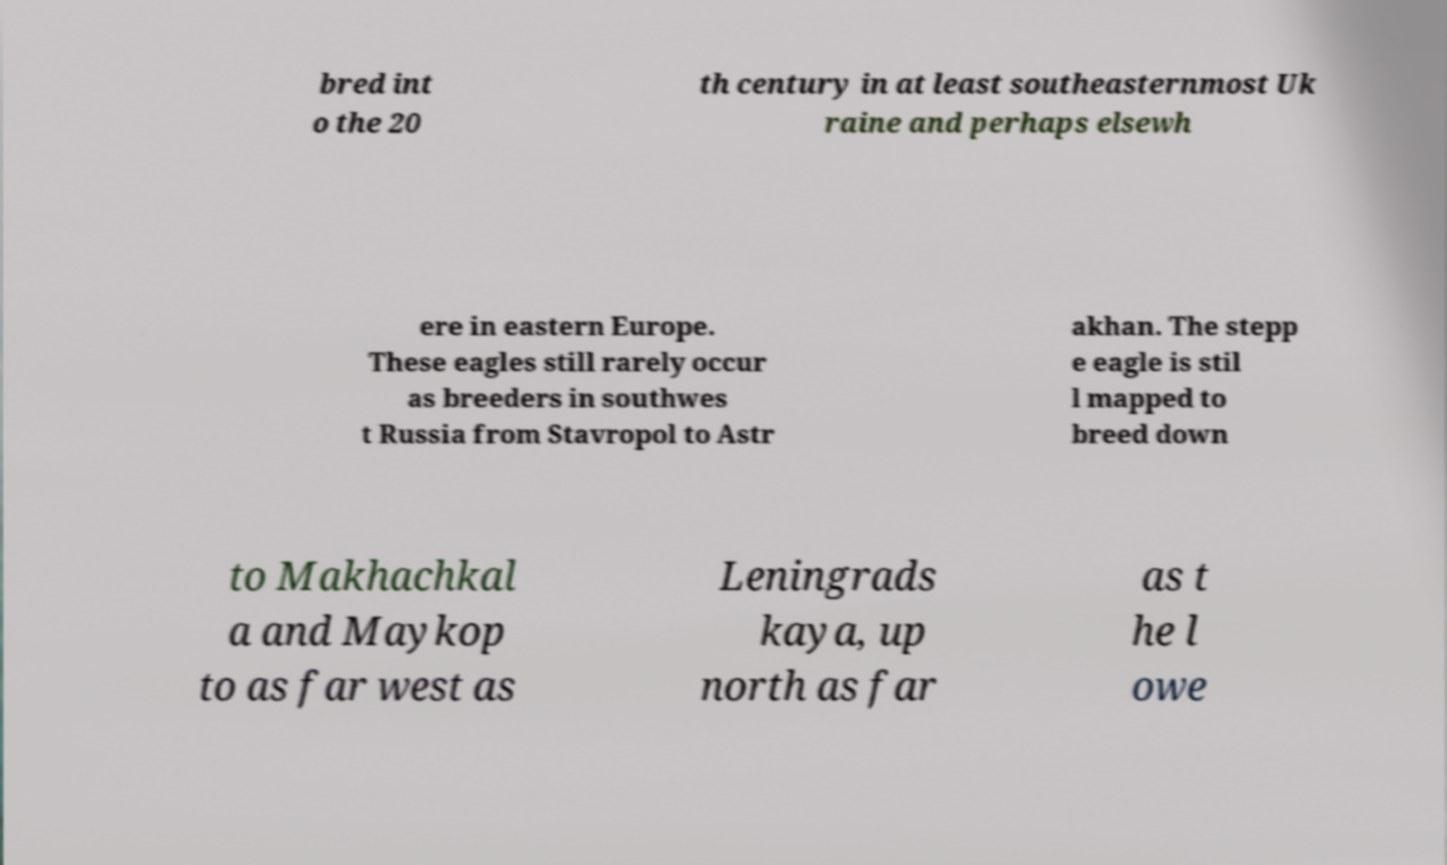For documentation purposes, I need the text within this image transcribed. Could you provide that? bred int o the 20 th century in at least southeasternmost Uk raine and perhaps elsewh ere in eastern Europe. These eagles still rarely occur as breeders in southwes t Russia from Stavropol to Astr akhan. The stepp e eagle is stil l mapped to breed down to Makhachkal a and Maykop to as far west as Leningrads kaya, up north as far as t he l owe 